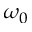<formula> <loc_0><loc_0><loc_500><loc_500>\omega _ { 0 }</formula> 